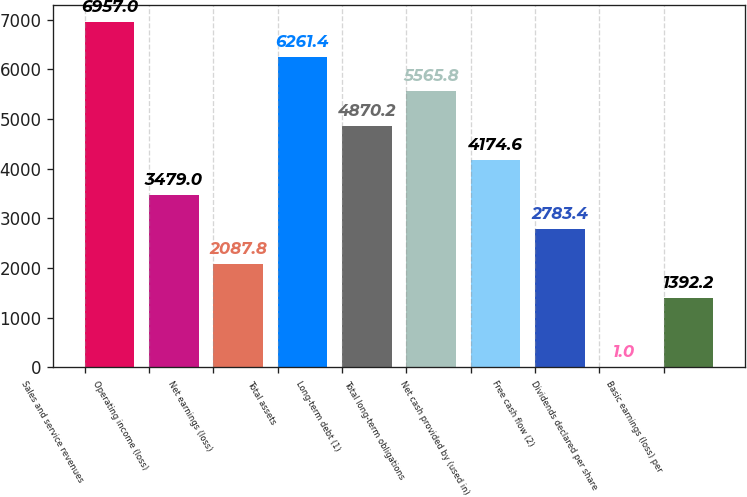Convert chart to OTSL. <chart><loc_0><loc_0><loc_500><loc_500><bar_chart><fcel>Sales and service revenues<fcel>Operating income (loss)<fcel>Net earnings (loss)<fcel>Total assets<fcel>Long-term debt (1)<fcel>Total long-term obligations<fcel>Net cash provided by (used in)<fcel>Free cash flow (2)<fcel>Dividends declared per share<fcel>Basic earnings (loss) per<nl><fcel>6957<fcel>3479<fcel>2087.8<fcel>6261.4<fcel>4870.2<fcel>5565.8<fcel>4174.6<fcel>2783.4<fcel>1<fcel>1392.2<nl></chart> 